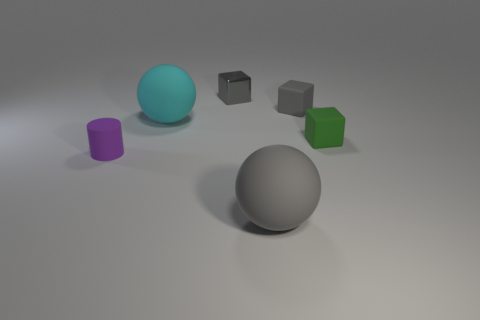Subtract all green matte cubes. How many cubes are left? 2 Add 4 tiny gray objects. How many objects exist? 10 Subtract all blue spheres. How many gray cubes are left? 2 Subtract all cylinders. How many objects are left? 5 Add 6 small yellow rubber objects. How many small yellow rubber objects exist? 6 Subtract all cyan balls. How many balls are left? 1 Subtract 0 red spheres. How many objects are left? 6 Subtract 1 spheres. How many spheres are left? 1 Subtract all green cubes. Subtract all yellow cylinders. How many cubes are left? 2 Subtract all balls. Subtract all purple rubber things. How many objects are left? 3 